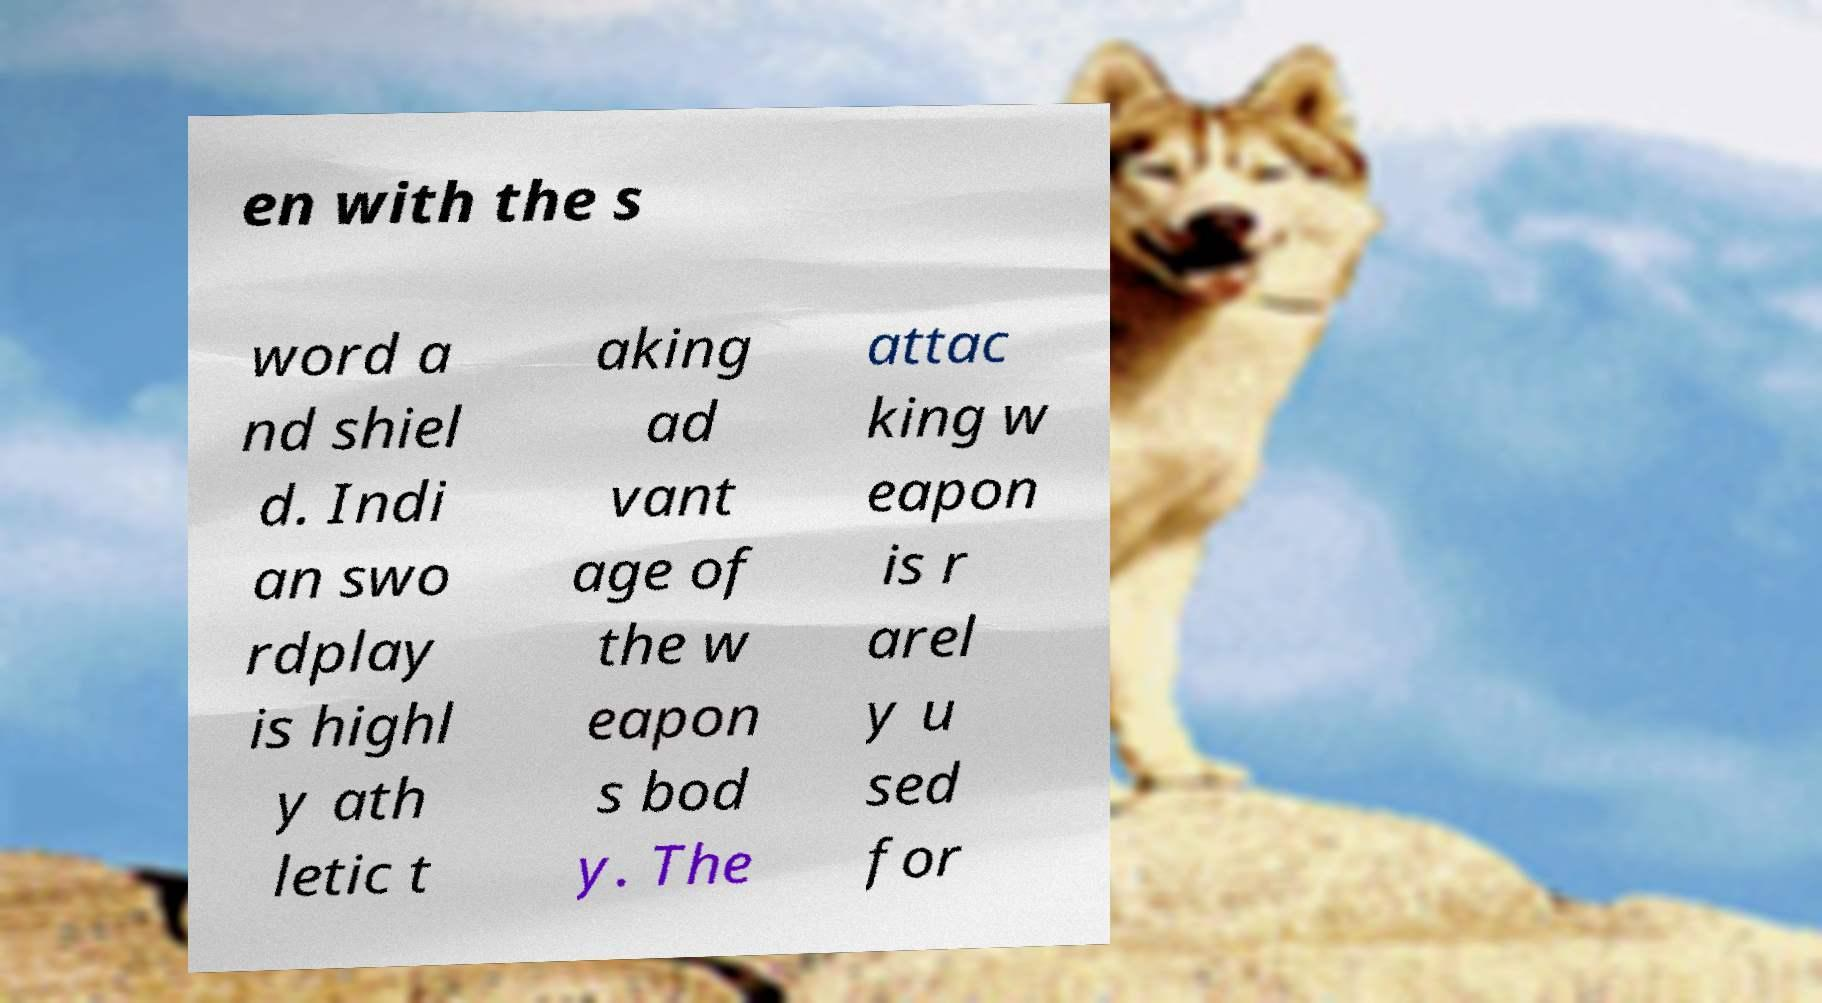For documentation purposes, I need the text within this image transcribed. Could you provide that? en with the s word a nd shiel d. Indi an swo rdplay is highl y ath letic t aking ad vant age of the w eapon s bod y. The attac king w eapon is r arel y u sed for 